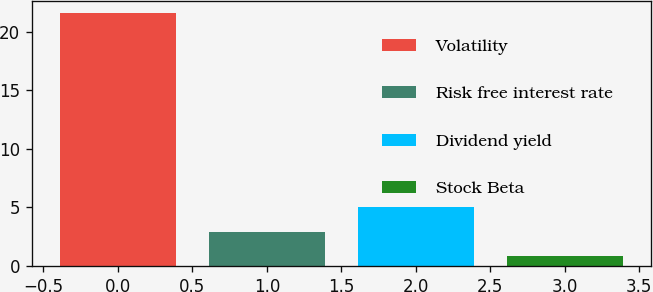Convert chart. <chart><loc_0><loc_0><loc_500><loc_500><bar_chart><fcel>Volatility<fcel>Risk free interest rate<fcel>Dividend yield<fcel>Stock Beta<nl><fcel>21.6<fcel>2.92<fcel>5<fcel>0.84<nl></chart> 